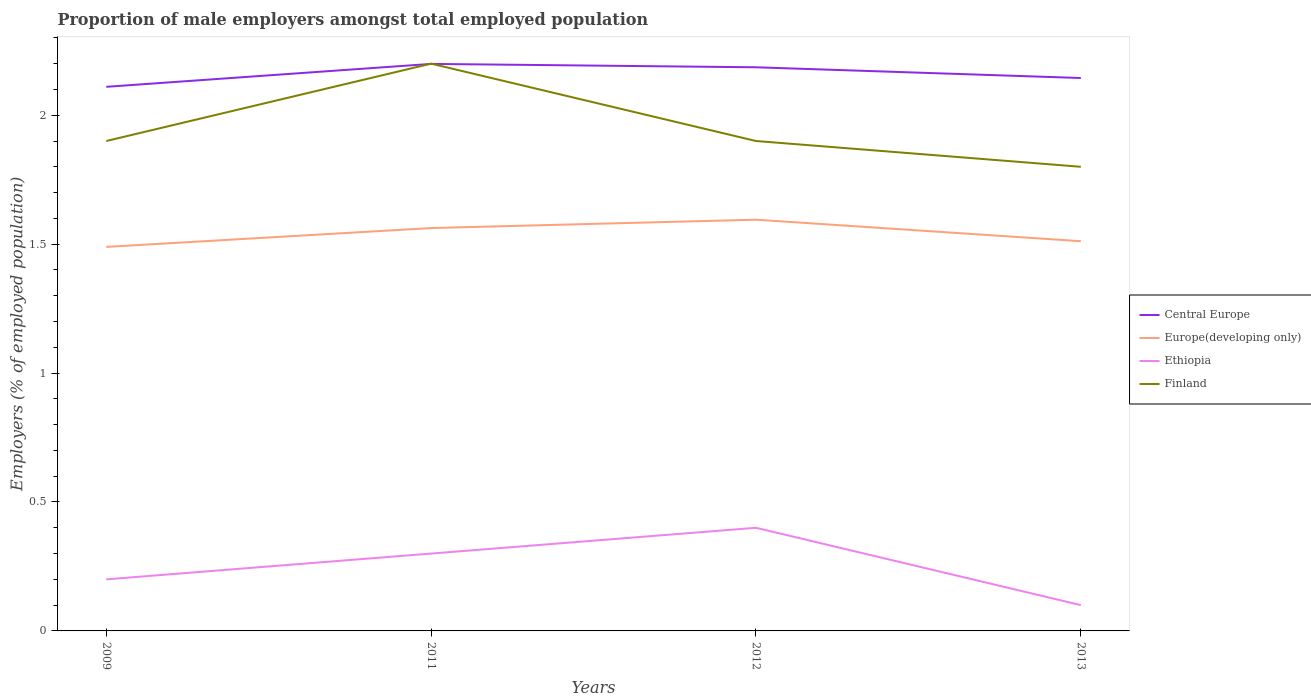How many different coloured lines are there?
Your answer should be compact. 4. Is the number of lines equal to the number of legend labels?
Offer a very short reply. Yes. Across all years, what is the maximum proportion of male employers in Finland?
Provide a short and direct response. 1.8. In which year was the proportion of male employers in Finland maximum?
Keep it short and to the point. 2013. What is the total proportion of male employers in Central Europe in the graph?
Your response must be concise. -0.03. What is the difference between the highest and the second highest proportion of male employers in Finland?
Provide a succinct answer. 0.4. How many lines are there?
Give a very brief answer. 4. Are the values on the major ticks of Y-axis written in scientific E-notation?
Provide a succinct answer. No. Does the graph contain any zero values?
Give a very brief answer. No. Does the graph contain grids?
Your answer should be compact. No. What is the title of the graph?
Your answer should be very brief. Proportion of male employers amongst total employed population. Does "Singapore" appear as one of the legend labels in the graph?
Your response must be concise. No. What is the label or title of the X-axis?
Offer a very short reply. Years. What is the label or title of the Y-axis?
Provide a succinct answer. Employers (% of employed population). What is the Employers (% of employed population) of Central Europe in 2009?
Offer a terse response. 2.11. What is the Employers (% of employed population) in Europe(developing only) in 2009?
Offer a terse response. 1.49. What is the Employers (% of employed population) of Ethiopia in 2009?
Provide a short and direct response. 0.2. What is the Employers (% of employed population) in Finland in 2009?
Make the answer very short. 1.9. What is the Employers (% of employed population) in Central Europe in 2011?
Provide a short and direct response. 2.2. What is the Employers (% of employed population) in Europe(developing only) in 2011?
Provide a succinct answer. 1.56. What is the Employers (% of employed population) of Ethiopia in 2011?
Provide a succinct answer. 0.3. What is the Employers (% of employed population) in Finland in 2011?
Provide a short and direct response. 2.2. What is the Employers (% of employed population) of Central Europe in 2012?
Provide a succinct answer. 2.19. What is the Employers (% of employed population) of Europe(developing only) in 2012?
Ensure brevity in your answer.  1.59. What is the Employers (% of employed population) in Ethiopia in 2012?
Your answer should be compact. 0.4. What is the Employers (% of employed population) in Finland in 2012?
Provide a short and direct response. 1.9. What is the Employers (% of employed population) of Central Europe in 2013?
Keep it short and to the point. 2.14. What is the Employers (% of employed population) of Europe(developing only) in 2013?
Your answer should be compact. 1.51. What is the Employers (% of employed population) in Ethiopia in 2013?
Your answer should be very brief. 0.1. What is the Employers (% of employed population) of Finland in 2013?
Provide a short and direct response. 1.8. Across all years, what is the maximum Employers (% of employed population) in Central Europe?
Your response must be concise. 2.2. Across all years, what is the maximum Employers (% of employed population) in Europe(developing only)?
Ensure brevity in your answer.  1.59. Across all years, what is the maximum Employers (% of employed population) of Ethiopia?
Offer a very short reply. 0.4. Across all years, what is the maximum Employers (% of employed population) of Finland?
Ensure brevity in your answer.  2.2. Across all years, what is the minimum Employers (% of employed population) of Central Europe?
Offer a terse response. 2.11. Across all years, what is the minimum Employers (% of employed population) of Europe(developing only)?
Your response must be concise. 1.49. Across all years, what is the minimum Employers (% of employed population) in Ethiopia?
Your answer should be compact. 0.1. Across all years, what is the minimum Employers (% of employed population) of Finland?
Ensure brevity in your answer.  1.8. What is the total Employers (% of employed population) in Central Europe in the graph?
Make the answer very short. 8.64. What is the total Employers (% of employed population) of Europe(developing only) in the graph?
Make the answer very short. 6.16. What is the difference between the Employers (% of employed population) in Central Europe in 2009 and that in 2011?
Provide a succinct answer. -0.09. What is the difference between the Employers (% of employed population) of Europe(developing only) in 2009 and that in 2011?
Offer a very short reply. -0.07. What is the difference between the Employers (% of employed population) of Central Europe in 2009 and that in 2012?
Keep it short and to the point. -0.08. What is the difference between the Employers (% of employed population) in Europe(developing only) in 2009 and that in 2012?
Your answer should be very brief. -0.11. What is the difference between the Employers (% of employed population) of Central Europe in 2009 and that in 2013?
Your answer should be compact. -0.03. What is the difference between the Employers (% of employed population) in Europe(developing only) in 2009 and that in 2013?
Provide a succinct answer. -0.02. What is the difference between the Employers (% of employed population) of Ethiopia in 2009 and that in 2013?
Offer a terse response. 0.1. What is the difference between the Employers (% of employed population) of Finland in 2009 and that in 2013?
Make the answer very short. 0.1. What is the difference between the Employers (% of employed population) in Central Europe in 2011 and that in 2012?
Provide a succinct answer. 0.01. What is the difference between the Employers (% of employed population) in Europe(developing only) in 2011 and that in 2012?
Offer a very short reply. -0.03. What is the difference between the Employers (% of employed population) in Ethiopia in 2011 and that in 2012?
Your answer should be very brief. -0.1. What is the difference between the Employers (% of employed population) of Finland in 2011 and that in 2012?
Your answer should be compact. 0.3. What is the difference between the Employers (% of employed population) of Central Europe in 2011 and that in 2013?
Provide a succinct answer. 0.05. What is the difference between the Employers (% of employed population) in Europe(developing only) in 2011 and that in 2013?
Make the answer very short. 0.05. What is the difference between the Employers (% of employed population) of Finland in 2011 and that in 2013?
Your answer should be compact. 0.4. What is the difference between the Employers (% of employed population) in Central Europe in 2012 and that in 2013?
Provide a short and direct response. 0.04. What is the difference between the Employers (% of employed population) in Europe(developing only) in 2012 and that in 2013?
Keep it short and to the point. 0.08. What is the difference between the Employers (% of employed population) in Ethiopia in 2012 and that in 2013?
Give a very brief answer. 0.3. What is the difference between the Employers (% of employed population) of Finland in 2012 and that in 2013?
Ensure brevity in your answer.  0.1. What is the difference between the Employers (% of employed population) of Central Europe in 2009 and the Employers (% of employed population) of Europe(developing only) in 2011?
Your answer should be compact. 0.55. What is the difference between the Employers (% of employed population) in Central Europe in 2009 and the Employers (% of employed population) in Ethiopia in 2011?
Provide a short and direct response. 1.81. What is the difference between the Employers (% of employed population) in Central Europe in 2009 and the Employers (% of employed population) in Finland in 2011?
Provide a succinct answer. -0.09. What is the difference between the Employers (% of employed population) of Europe(developing only) in 2009 and the Employers (% of employed population) of Ethiopia in 2011?
Provide a short and direct response. 1.19. What is the difference between the Employers (% of employed population) of Europe(developing only) in 2009 and the Employers (% of employed population) of Finland in 2011?
Make the answer very short. -0.71. What is the difference between the Employers (% of employed population) in Ethiopia in 2009 and the Employers (% of employed population) in Finland in 2011?
Your response must be concise. -2. What is the difference between the Employers (% of employed population) of Central Europe in 2009 and the Employers (% of employed population) of Europe(developing only) in 2012?
Your answer should be very brief. 0.52. What is the difference between the Employers (% of employed population) in Central Europe in 2009 and the Employers (% of employed population) in Ethiopia in 2012?
Provide a short and direct response. 1.71. What is the difference between the Employers (% of employed population) of Central Europe in 2009 and the Employers (% of employed population) of Finland in 2012?
Give a very brief answer. 0.21. What is the difference between the Employers (% of employed population) of Europe(developing only) in 2009 and the Employers (% of employed population) of Ethiopia in 2012?
Your answer should be very brief. 1.09. What is the difference between the Employers (% of employed population) of Europe(developing only) in 2009 and the Employers (% of employed population) of Finland in 2012?
Give a very brief answer. -0.41. What is the difference between the Employers (% of employed population) in Central Europe in 2009 and the Employers (% of employed population) in Europe(developing only) in 2013?
Offer a terse response. 0.6. What is the difference between the Employers (% of employed population) of Central Europe in 2009 and the Employers (% of employed population) of Ethiopia in 2013?
Keep it short and to the point. 2.01. What is the difference between the Employers (% of employed population) of Central Europe in 2009 and the Employers (% of employed population) of Finland in 2013?
Ensure brevity in your answer.  0.31. What is the difference between the Employers (% of employed population) of Europe(developing only) in 2009 and the Employers (% of employed population) of Ethiopia in 2013?
Ensure brevity in your answer.  1.39. What is the difference between the Employers (% of employed population) of Europe(developing only) in 2009 and the Employers (% of employed population) of Finland in 2013?
Make the answer very short. -0.31. What is the difference between the Employers (% of employed population) of Central Europe in 2011 and the Employers (% of employed population) of Europe(developing only) in 2012?
Provide a short and direct response. 0.6. What is the difference between the Employers (% of employed population) in Central Europe in 2011 and the Employers (% of employed population) in Ethiopia in 2012?
Your response must be concise. 1.8. What is the difference between the Employers (% of employed population) in Central Europe in 2011 and the Employers (% of employed population) in Finland in 2012?
Offer a terse response. 0.3. What is the difference between the Employers (% of employed population) in Europe(developing only) in 2011 and the Employers (% of employed population) in Ethiopia in 2012?
Your response must be concise. 1.16. What is the difference between the Employers (% of employed population) in Europe(developing only) in 2011 and the Employers (% of employed population) in Finland in 2012?
Your response must be concise. -0.34. What is the difference between the Employers (% of employed population) of Central Europe in 2011 and the Employers (% of employed population) of Europe(developing only) in 2013?
Ensure brevity in your answer.  0.69. What is the difference between the Employers (% of employed population) of Central Europe in 2011 and the Employers (% of employed population) of Ethiopia in 2013?
Offer a very short reply. 2.1. What is the difference between the Employers (% of employed population) of Central Europe in 2011 and the Employers (% of employed population) of Finland in 2013?
Your answer should be compact. 0.4. What is the difference between the Employers (% of employed population) of Europe(developing only) in 2011 and the Employers (% of employed population) of Ethiopia in 2013?
Your response must be concise. 1.46. What is the difference between the Employers (% of employed population) of Europe(developing only) in 2011 and the Employers (% of employed population) of Finland in 2013?
Your answer should be very brief. -0.24. What is the difference between the Employers (% of employed population) in Ethiopia in 2011 and the Employers (% of employed population) in Finland in 2013?
Ensure brevity in your answer.  -1.5. What is the difference between the Employers (% of employed population) in Central Europe in 2012 and the Employers (% of employed population) in Europe(developing only) in 2013?
Make the answer very short. 0.67. What is the difference between the Employers (% of employed population) of Central Europe in 2012 and the Employers (% of employed population) of Ethiopia in 2013?
Your answer should be very brief. 2.09. What is the difference between the Employers (% of employed population) of Central Europe in 2012 and the Employers (% of employed population) of Finland in 2013?
Ensure brevity in your answer.  0.39. What is the difference between the Employers (% of employed population) in Europe(developing only) in 2012 and the Employers (% of employed population) in Ethiopia in 2013?
Ensure brevity in your answer.  1.49. What is the difference between the Employers (% of employed population) of Europe(developing only) in 2012 and the Employers (% of employed population) of Finland in 2013?
Offer a very short reply. -0.21. What is the average Employers (% of employed population) in Central Europe per year?
Your response must be concise. 2.16. What is the average Employers (% of employed population) in Europe(developing only) per year?
Your answer should be compact. 1.54. What is the average Employers (% of employed population) in Finland per year?
Make the answer very short. 1.95. In the year 2009, what is the difference between the Employers (% of employed population) of Central Europe and Employers (% of employed population) of Europe(developing only)?
Ensure brevity in your answer.  0.62. In the year 2009, what is the difference between the Employers (% of employed population) in Central Europe and Employers (% of employed population) in Ethiopia?
Your answer should be very brief. 1.91. In the year 2009, what is the difference between the Employers (% of employed population) of Central Europe and Employers (% of employed population) of Finland?
Your answer should be very brief. 0.21. In the year 2009, what is the difference between the Employers (% of employed population) of Europe(developing only) and Employers (% of employed population) of Ethiopia?
Provide a short and direct response. 1.29. In the year 2009, what is the difference between the Employers (% of employed population) of Europe(developing only) and Employers (% of employed population) of Finland?
Give a very brief answer. -0.41. In the year 2009, what is the difference between the Employers (% of employed population) in Ethiopia and Employers (% of employed population) in Finland?
Keep it short and to the point. -1.7. In the year 2011, what is the difference between the Employers (% of employed population) in Central Europe and Employers (% of employed population) in Europe(developing only)?
Offer a very short reply. 0.64. In the year 2011, what is the difference between the Employers (% of employed population) of Central Europe and Employers (% of employed population) of Ethiopia?
Keep it short and to the point. 1.9. In the year 2011, what is the difference between the Employers (% of employed population) in Central Europe and Employers (% of employed population) in Finland?
Provide a succinct answer. -0. In the year 2011, what is the difference between the Employers (% of employed population) of Europe(developing only) and Employers (% of employed population) of Ethiopia?
Provide a short and direct response. 1.26. In the year 2011, what is the difference between the Employers (% of employed population) of Europe(developing only) and Employers (% of employed population) of Finland?
Keep it short and to the point. -0.64. In the year 2011, what is the difference between the Employers (% of employed population) in Ethiopia and Employers (% of employed population) in Finland?
Make the answer very short. -1.9. In the year 2012, what is the difference between the Employers (% of employed population) of Central Europe and Employers (% of employed population) of Europe(developing only)?
Your answer should be very brief. 0.59. In the year 2012, what is the difference between the Employers (% of employed population) of Central Europe and Employers (% of employed population) of Ethiopia?
Provide a short and direct response. 1.79. In the year 2012, what is the difference between the Employers (% of employed population) in Central Europe and Employers (% of employed population) in Finland?
Keep it short and to the point. 0.29. In the year 2012, what is the difference between the Employers (% of employed population) in Europe(developing only) and Employers (% of employed population) in Ethiopia?
Provide a succinct answer. 1.19. In the year 2012, what is the difference between the Employers (% of employed population) in Europe(developing only) and Employers (% of employed population) in Finland?
Ensure brevity in your answer.  -0.31. In the year 2012, what is the difference between the Employers (% of employed population) in Ethiopia and Employers (% of employed population) in Finland?
Provide a succinct answer. -1.5. In the year 2013, what is the difference between the Employers (% of employed population) of Central Europe and Employers (% of employed population) of Europe(developing only)?
Provide a short and direct response. 0.63. In the year 2013, what is the difference between the Employers (% of employed population) of Central Europe and Employers (% of employed population) of Ethiopia?
Provide a short and direct response. 2.04. In the year 2013, what is the difference between the Employers (% of employed population) of Central Europe and Employers (% of employed population) of Finland?
Make the answer very short. 0.34. In the year 2013, what is the difference between the Employers (% of employed population) of Europe(developing only) and Employers (% of employed population) of Ethiopia?
Provide a short and direct response. 1.41. In the year 2013, what is the difference between the Employers (% of employed population) of Europe(developing only) and Employers (% of employed population) of Finland?
Offer a very short reply. -0.29. In the year 2013, what is the difference between the Employers (% of employed population) in Ethiopia and Employers (% of employed population) in Finland?
Offer a terse response. -1.7. What is the ratio of the Employers (% of employed population) in Central Europe in 2009 to that in 2011?
Your answer should be very brief. 0.96. What is the ratio of the Employers (% of employed population) in Europe(developing only) in 2009 to that in 2011?
Your response must be concise. 0.95. What is the ratio of the Employers (% of employed population) in Finland in 2009 to that in 2011?
Your response must be concise. 0.86. What is the ratio of the Employers (% of employed population) in Central Europe in 2009 to that in 2012?
Your answer should be very brief. 0.97. What is the ratio of the Employers (% of employed population) in Europe(developing only) in 2009 to that in 2012?
Give a very brief answer. 0.93. What is the ratio of the Employers (% of employed population) in Central Europe in 2009 to that in 2013?
Your answer should be very brief. 0.98. What is the ratio of the Employers (% of employed population) in Europe(developing only) in 2009 to that in 2013?
Provide a short and direct response. 0.99. What is the ratio of the Employers (% of employed population) of Finland in 2009 to that in 2013?
Provide a short and direct response. 1.06. What is the ratio of the Employers (% of employed population) in Europe(developing only) in 2011 to that in 2012?
Offer a terse response. 0.98. What is the ratio of the Employers (% of employed population) in Finland in 2011 to that in 2012?
Make the answer very short. 1.16. What is the ratio of the Employers (% of employed population) of Central Europe in 2011 to that in 2013?
Offer a very short reply. 1.03. What is the ratio of the Employers (% of employed population) of Europe(developing only) in 2011 to that in 2013?
Your answer should be very brief. 1.03. What is the ratio of the Employers (% of employed population) of Finland in 2011 to that in 2013?
Make the answer very short. 1.22. What is the ratio of the Employers (% of employed population) in Central Europe in 2012 to that in 2013?
Ensure brevity in your answer.  1.02. What is the ratio of the Employers (% of employed population) of Europe(developing only) in 2012 to that in 2013?
Your answer should be compact. 1.06. What is the ratio of the Employers (% of employed population) in Ethiopia in 2012 to that in 2013?
Your answer should be very brief. 4. What is the ratio of the Employers (% of employed population) in Finland in 2012 to that in 2013?
Your answer should be compact. 1.06. What is the difference between the highest and the second highest Employers (% of employed population) in Central Europe?
Give a very brief answer. 0.01. What is the difference between the highest and the second highest Employers (% of employed population) in Europe(developing only)?
Your answer should be very brief. 0.03. What is the difference between the highest and the second highest Employers (% of employed population) in Ethiopia?
Make the answer very short. 0.1. What is the difference between the highest and the second highest Employers (% of employed population) in Finland?
Provide a short and direct response. 0.3. What is the difference between the highest and the lowest Employers (% of employed population) in Central Europe?
Your response must be concise. 0.09. What is the difference between the highest and the lowest Employers (% of employed population) in Europe(developing only)?
Your response must be concise. 0.11. What is the difference between the highest and the lowest Employers (% of employed population) of Finland?
Offer a terse response. 0.4. 